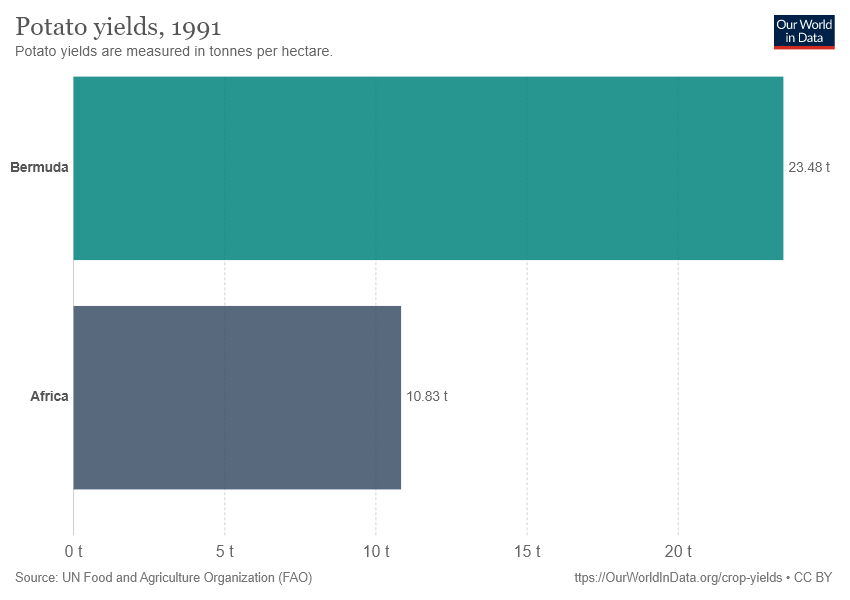Give some essential details in this illustration. The average of Bermuda and Africa combined is 17.155. Bermuda produces, on average, 23.48 metric tonnes of potatoes per hectare. 